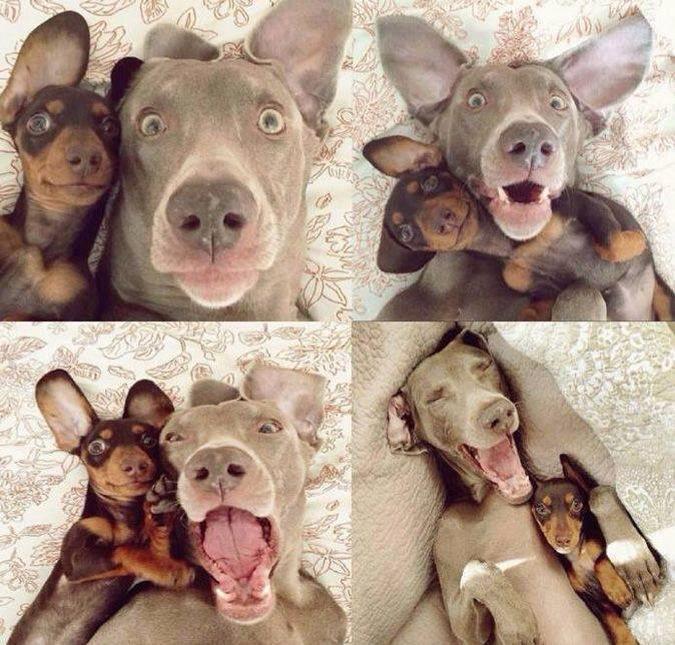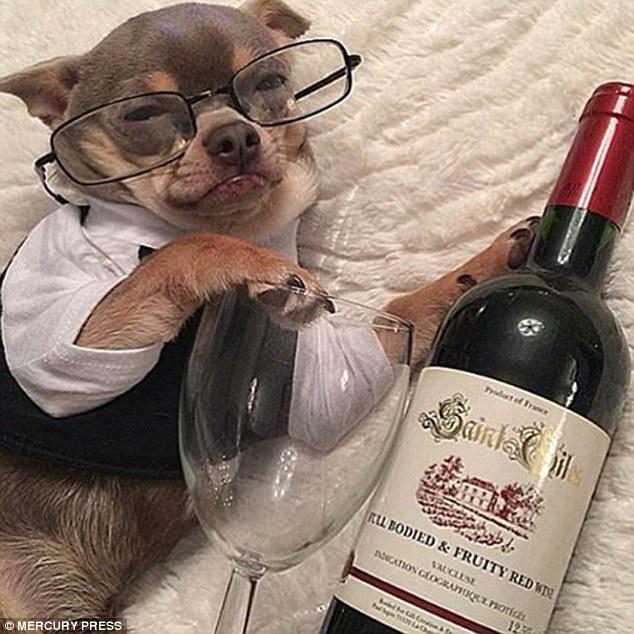The first image is the image on the left, the second image is the image on the right. Considering the images on both sides, is "At least two dogs are snuggling together." valid? Answer yes or no. Yes. The first image is the image on the left, the second image is the image on the right. Assess this claim about the two images: "All of the dogs are real and some are dressed like humans.". Correct or not? Answer yes or no. Yes. 